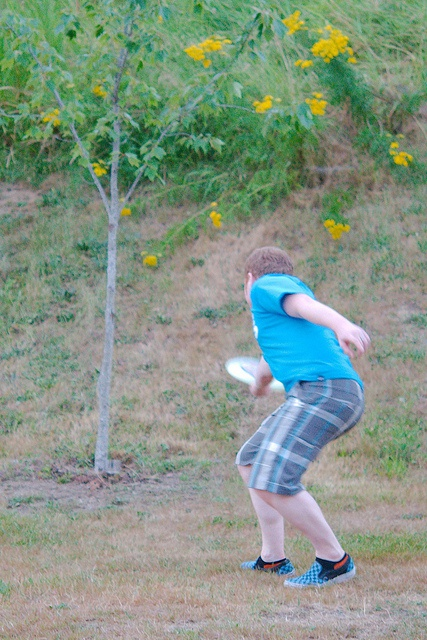Describe the objects in this image and their specific colors. I can see people in olive, darkgray, lightblue, and lavender tones and frisbee in olive, white, lightblue, and darkgray tones in this image. 